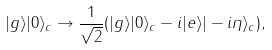Convert formula to latex. <formula><loc_0><loc_0><loc_500><loc_500>| g \rangle | 0 \rangle _ { c } \rightarrow \frac { 1 } { \sqrt { 2 } } ( | g \rangle | 0 \rangle _ { c } - i | e \rangle | - i \eta \rangle _ { c } ) ,</formula> 